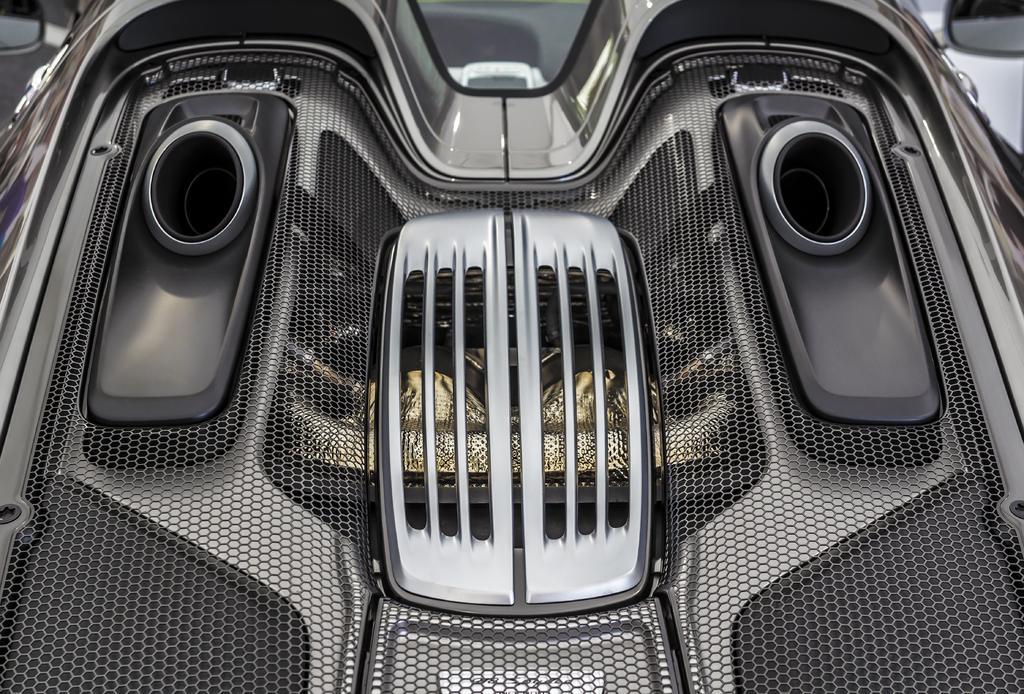Please provide a concise description of this image. In this image there is an object which is black and grey in color. It is looking like a vehicle. 